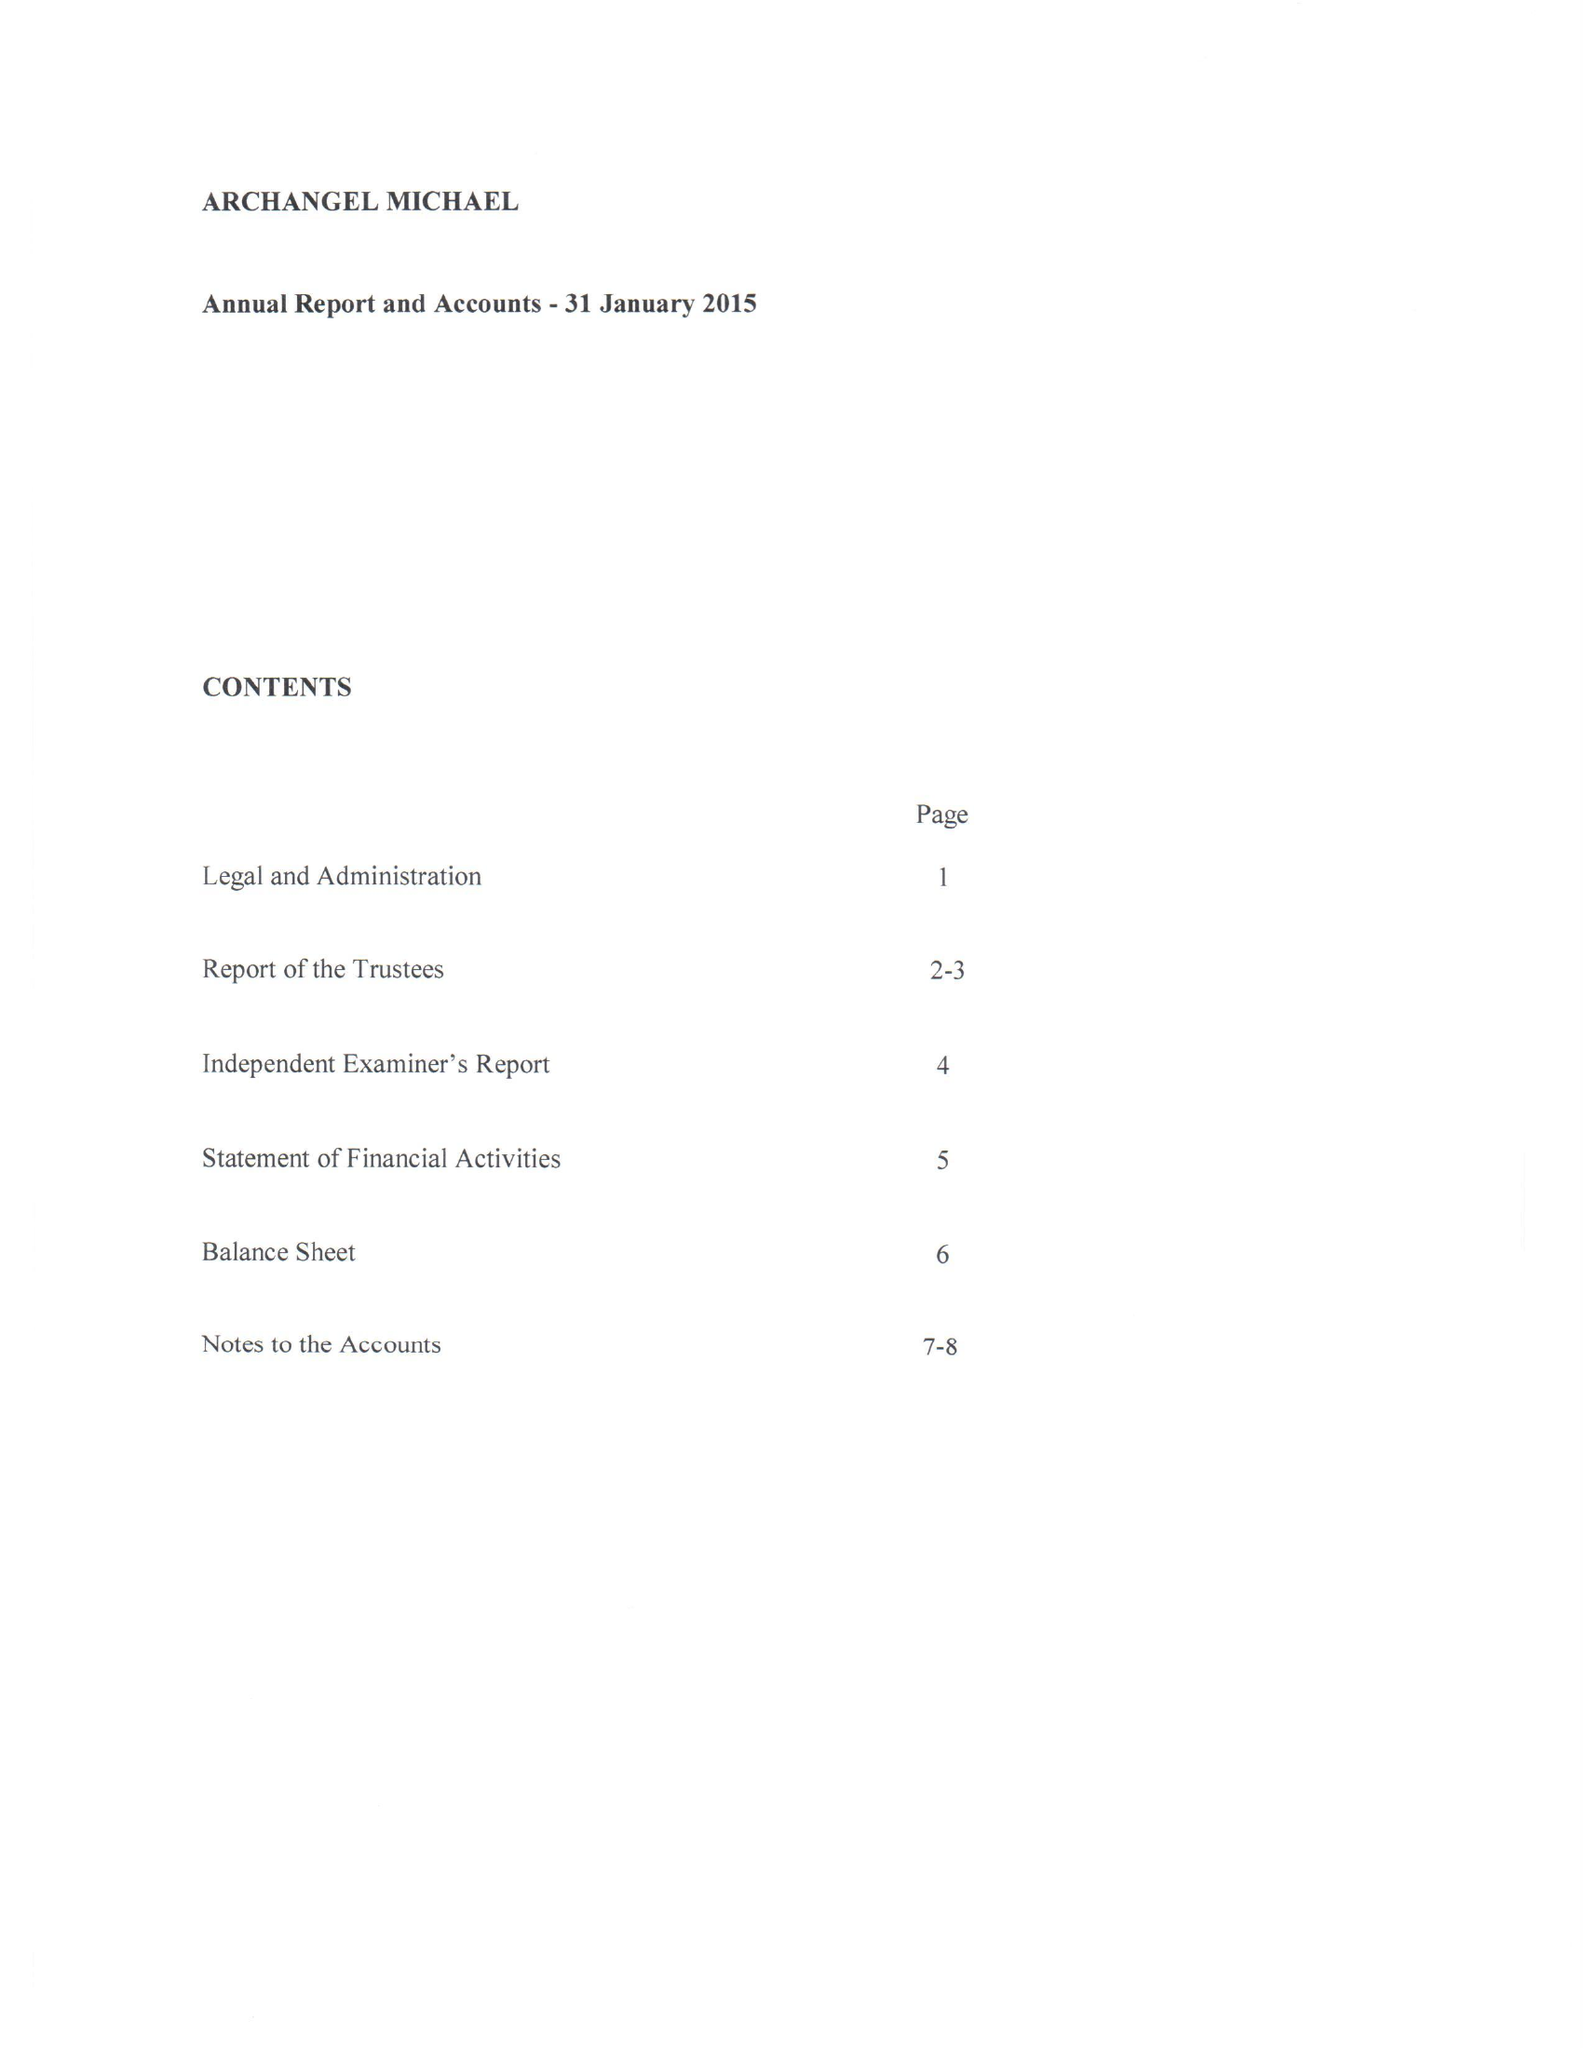What is the value for the income_annually_in_british_pounds?
Answer the question using a single word or phrase. 72791.00 